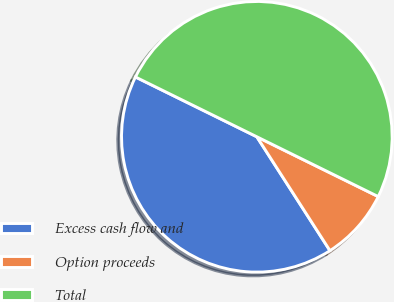Convert chart. <chart><loc_0><loc_0><loc_500><loc_500><pie_chart><fcel>Excess cash flow and<fcel>Option proceeds<fcel>Total<nl><fcel>41.37%<fcel>8.63%<fcel>50.0%<nl></chart> 